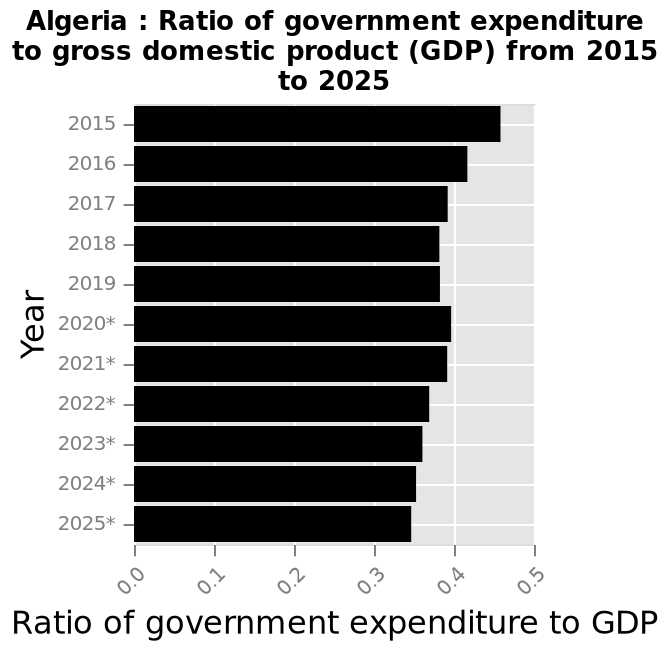<image>
What is being measured by the ratio of government expenditure to GDP? The ratio of government expenditure to GDP measures the proportion of a country's expenditure relative to its total economic output. please summary the statistics and relations of the chart The highest ratio of government expenditure to GDP was in 2015 (0.45). The lowest ratio is predicted to be 2025 (0.34). Apart from.2015 and 2016, all other years will have a ratio below 0.4. What was the highest ratio of government expenditure to GDP?  The highest ratio of government expenditure to GDP was in 2015 (0.45). What is the predicted lowest ratio of government expenditure to GDP?  The lowest ratio is predicted to be in 2025 (0.34). Is the highest ratio predicted to be in 2025 (0.34)? No. The lowest ratio is predicted to be in 2025 (0.34). 